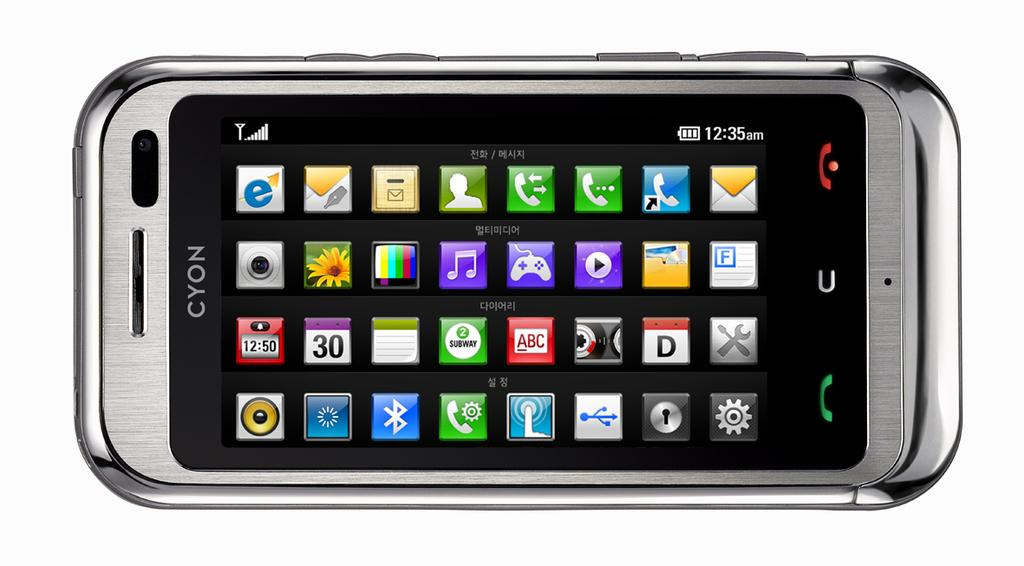<image>
Share a concise interpretation of the image provided. A silver Cyon cellphone shows several apps on its screen. 